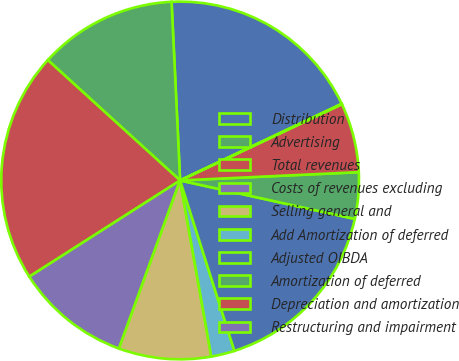Convert chart. <chart><loc_0><loc_0><loc_500><loc_500><pie_chart><fcel>Distribution<fcel>Advertising<fcel>Total revenues<fcel>Costs of revenues excluding<fcel>Selling general and<fcel>Add Amortization of deferred<fcel>Adjusted OIBDA<fcel>Amortization of deferred<fcel>Depreciation and amortization<fcel>Restructuring and impairment<nl><fcel>18.71%<fcel>12.49%<fcel>20.79%<fcel>10.41%<fcel>8.34%<fcel>2.12%<fcel>16.64%<fcel>4.19%<fcel>6.27%<fcel>0.04%<nl></chart> 